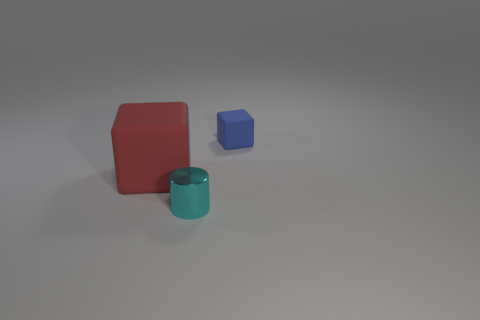Is there any other thing that has the same size as the red thing?
Provide a short and direct response. No. There is a cube in front of the tiny blue matte object; what is it made of?
Ensure brevity in your answer.  Rubber. How many things are matte cubes that are left of the small cylinder or tiny things that are behind the red rubber object?
Keep it short and to the point. 2. Are there any red rubber things of the same size as the shiny object?
Offer a terse response. No. There is a object that is both to the right of the big rubber block and behind the tiny cyan cylinder; what material is it made of?
Offer a terse response. Rubber. How many matte objects are cubes or small cylinders?
Ensure brevity in your answer.  2. What shape is the object that is made of the same material as the red cube?
Your answer should be very brief. Cube. How many objects are both in front of the tiny cube and to the right of the big cube?
Offer a very short reply. 1. Is there anything else that has the same shape as the metallic thing?
Offer a terse response. No. There is a object that is behind the large red rubber object; what is its size?
Keep it short and to the point. Small. 